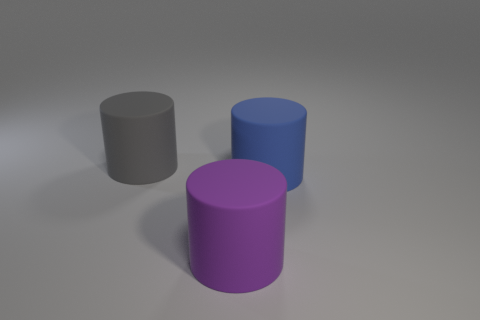There is a gray cylinder that is the same material as the purple thing; what is its size?
Make the answer very short. Large. There is a large thing that is in front of the cylinder to the right of the purple cylinder; what color is it?
Give a very brief answer. Purple. There is a big purple object; is it the same shape as the rubber object behind the large blue matte object?
Provide a succinct answer. Yes. How many rubber things have the same size as the purple matte cylinder?
Make the answer very short. 2. The big thing on the right side of the big purple matte cylinder has what shape?
Keep it short and to the point. Cylinder. What is the shape of the purple thing that is the same material as the gray cylinder?
Provide a short and direct response. Cylinder. What number of objects are either cylinders right of the big purple object or big things that are in front of the blue matte cylinder?
Keep it short and to the point. 2. How many rubber objects are purple cylinders or gray cylinders?
Offer a terse response. 2. Is the material of the big blue object the same as the purple thing?
Provide a short and direct response. Yes. Is there a large gray cylinder behind the cylinder behind the large object that is to the right of the purple matte cylinder?
Your answer should be very brief. No. 